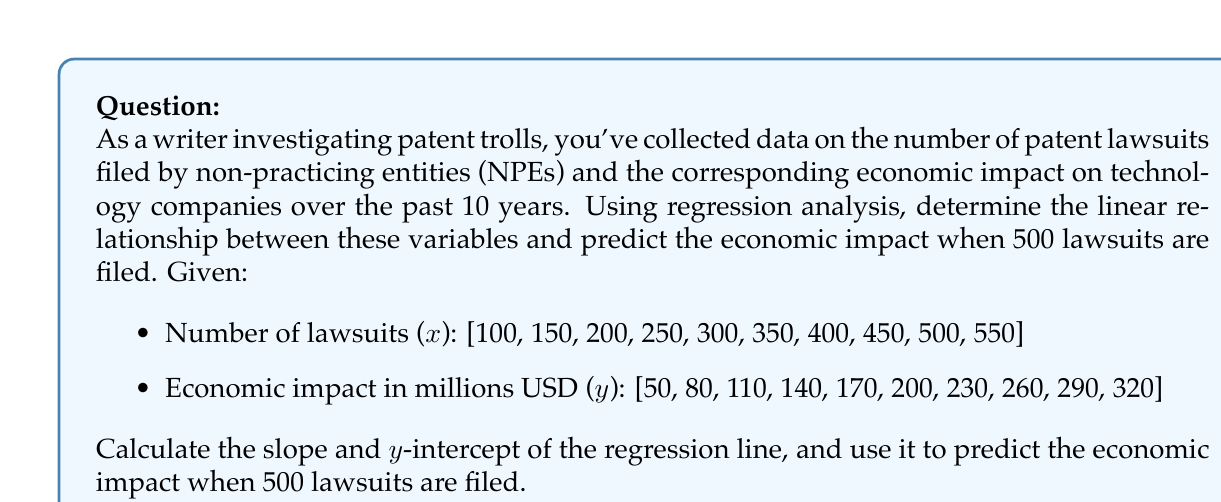Teach me how to tackle this problem. To solve this problem, we'll use simple linear regression analysis. The steps are as follows:

1. Calculate the means of x and y:
   $$\bar{x} = \frac{\sum x}{n} = \frac{3250}{10} = 325$$
   $$\bar{y} = \frac{\sum y}{n} = \frac{1850}{10} = 185$$

2. Calculate the slope (m) using the formula:
   $$m = \frac{\sum(x - \bar{x})(y - \bar{y})}{\sum(x - \bar{x})^2}$$

3. Calculate the y-intercept (b) using the formula:
   $$b = \bar{y} - m\bar{x}$$

4. Use the regression equation $y = mx + b$ to predict the economic impact for 500 lawsuits.

Step 2: Calculating the slope (m)
$$\sum(x - \bar{x})(y - \bar{y}) = 206250$$
$$\sum(x - \bar{x})^2 = 412500$$
$$m = \frac{206250}{412500} = 0.5$$

Step 3: Calculating the y-intercept (b)
$$b = 185 - 0.5(325) = 22.5$$

The regression equation is:
$$y = 0.5x + 22.5$$

Step 4: Predicting the economic impact for 500 lawsuits
$$y = 0.5(500) + 22.5 = 272.5$$

Therefore, when 500 lawsuits are filed, the predicted economic impact is $272.5 million.
Answer: $272.5 million 